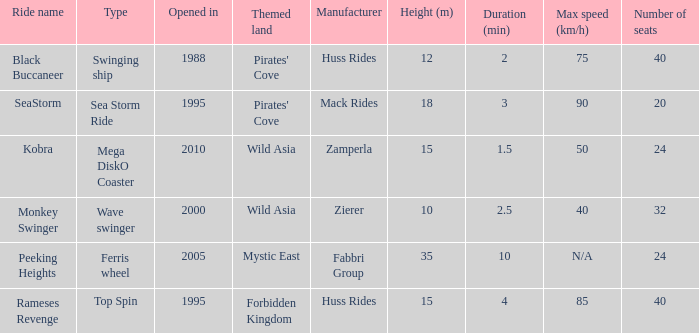What ride was manufactured by Zierer? Monkey Swinger. 